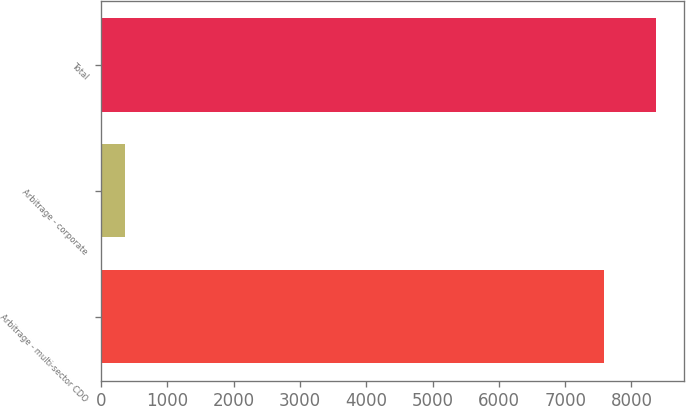Convert chart. <chart><loc_0><loc_0><loc_500><loc_500><bar_chart><fcel>Arbitrage - multi-sector CDO<fcel>Arbitrage - corporate<fcel>Total<nl><fcel>7590<fcel>368<fcel>8370.2<nl></chart> 